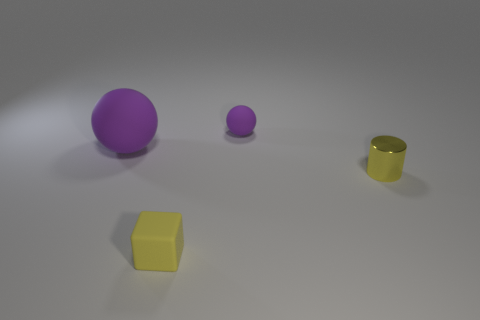Can you speculate on what the purple objects might be used for? The larger purple object resembles a ball, which could be used for recreational activities such as playing catch or various ball games. The smaller one could be a miniature version, perhaps serving as a toy or a decorative item. 